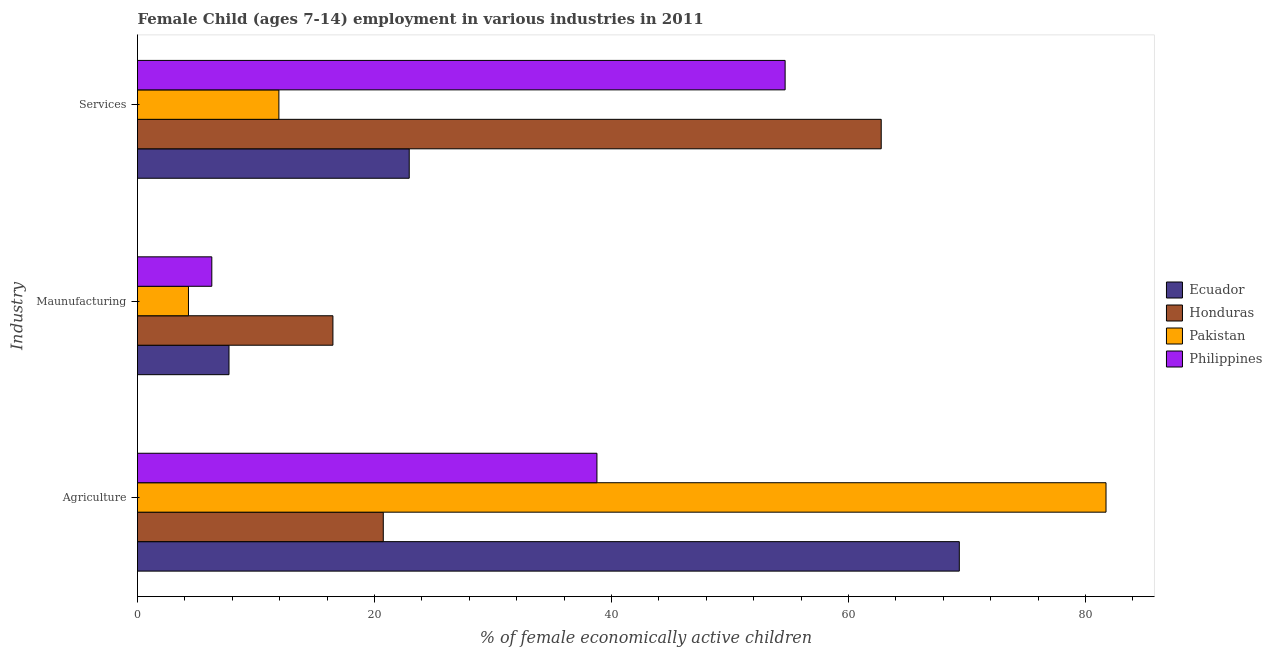How many different coloured bars are there?
Your response must be concise. 4. How many groups of bars are there?
Ensure brevity in your answer.  3. How many bars are there on the 3rd tick from the bottom?
Your answer should be very brief. 4. What is the label of the 3rd group of bars from the top?
Give a very brief answer. Agriculture. What is the percentage of economically active children in services in Pakistan?
Offer a very short reply. 11.93. Across all countries, what is the maximum percentage of economically active children in manufacturing?
Make the answer very short. 16.49. Across all countries, what is the minimum percentage of economically active children in agriculture?
Offer a very short reply. 20.74. What is the total percentage of economically active children in manufacturing in the graph?
Your response must be concise. 34.78. What is the difference between the percentage of economically active children in agriculture in Ecuador and that in Philippines?
Ensure brevity in your answer.  30.58. What is the difference between the percentage of economically active children in services in Pakistan and the percentage of economically active children in manufacturing in Philippines?
Keep it short and to the point. 5.66. What is the average percentage of economically active children in agriculture per country?
Make the answer very short. 52.65. What is the difference between the percentage of economically active children in manufacturing and percentage of economically active children in services in Pakistan?
Provide a short and direct response. -7.63. In how many countries, is the percentage of economically active children in services greater than 64 %?
Your answer should be very brief. 0. What is the ratio of the percentage of economically active children in agriculture in Honduras to that in Ecuador?
Offer a very short reply. 0.3. Is the difference between the percentage of economically active children in services in Ecuador and Honduras greater than the difference between the percentage of economically active children in agriculture in Ecuador and Honduras?
Your answer should be compact. No. What is the difference between the highest and the second highest percentage of economically active children in services?
Keep it short and to the point. 8.11. What is the difference between the highest and the lowest percentage of economically active children in services?
Give a very brief answer. 50.83. In how many countries, is the percentage of economically active children in manufacturing greater than the average percentage of economically active children in manufacturing taken over all countries?
Your answer should be very brief. 1. What does the 2nd bar from the top in Services represents?
Provide a succinct answer. Pakistan. What does the 2nd bar from the bottom in Services represents?
Make the answer very short. Honduras. Is it the case that in every country, the sum of the percentage of economically active children in agriculture and percentage of economically active children in manufacturing is greater than the percentage of economically active children in services?
Give a very brief answer. No. What is the difference between two consecutive major ticks on the X-axis?
Offer a very short reply. 20. How many legend labels are there?
Your response must be concise. 4. What is the title of the graph?
Ensure brevity in your answer.  Female Child (ages 7-14) employment in various industries in 2011. What is the label or title of the X-axis?
Offer a very short reply. % of female economically active children. What is the label or title of the Y-axis?
Your answer should be very brief. Industry. What is the % of female economically active children in Ecuador in Agriculture?
Give a very brief answer. 69.35. What is the % of female economically active children of Honduras in Agriculture?
Your response must be concise. 20.74. What is the % of female economically active children of Pakistan in Agriculture?
Your response must be concise. 81.73. What is the % of female economically active children in Philippines in Agriculture?
Keep it short and to the point. 38.77. What is the % of female economically active children in Ecuador in Maunufacturing?
Keep it short and to the point. 7.72. What is the % of female economically active children in Honduras in Maunufacturing?
Give a very brief answer. 16.49. What is the % of female economically active children of Philippines in Maunufacturing?
Your answer should be compact. 6.27. What is the % of female economically active children in Ecuador in Services?
Ensure brevity in your answer.  22.93. What is the % of female economically active children in Honduras in Services?
Make the answer very short. 62.76. What is the % of female economically active children in Pakistan in Services?
Offer a terse response. 11.93. What is the % of female economically active children in Philippines in Services?
Offer a terse response. 54.65. Across all Industry, what is the maximum % of female economically active children of Ecuador?
Provide a succinct answer. 69.35. Across all Industry, what is the maximum % of female economically active children in Honduras?
Provide a succinct answer. 62.76. Across all Industry, what is the maximum % of female economically active children in Pakistan?
Ensure brevity in your answer.  81.73. Across all Industry, what is the maximum % of female economically active children in Philippines?
Ensure brevity in your answer.  54.65. Across all Industry, what is the minimum % of female economically active children of Ecuador?
Provide a short and direct response. 7.72. Across all Industry, what is the minimum % of female economically active children of Honduras?
Your answer should be compact. 16.49. Across all Industry, what is the minimum % of female economically active children of Philippines?
Make the answer very short. 6.27. What is the total % of female economically active children in Honduras in the graph?
Your response must be concise. 99.99. What is the total % of female economically active children of Pakistan in the graph?
Make the answer very short. 97.96. What is the total % of female economically active children in Philippines in the graph?
Provide a succinct answer. 99.69. What is the difference between the % of female economically active children of Ecuador in Agriculture and that in Maunufacturing?
Ensure brevity in your answer.  61.63. What is the difference between the % of female economically active children of Honduras in Agriculture and that in Maunufacturing?
Keep it short and to the point. 4.25. What is the difference between the % of female economically active children in Pakistan in Agriculture and that in Maunufacturing?
Your response must be concise. 77.43. What is the difference between the % of female economically active children in Philippines in Agriculture and that in Maunufacturing?
Offer a very short reply. 32.5. What is the difference between the % of female economically active children in Ecuador in Agriculture and that in Services?
Make the answer very short. 46.42. What is the difference between the % of female economically active children of Honduras in Agriculture and that in Services?
Provide a succinct answer. -42.02. What is the difference between the % of female economically active children of Pakistan in Agriculture and that in Services?
Offer a very short reply. 69.8. What is the difference between the % of female economically active children of Philippines in Agriculture and that in Services?
Give a very brief answer. -15.88. What is the difference between the % of female economically active children of Ecuador in Maunufacturing and that in Services?
Offer a terse response. -15.21. What is the difference between the % of female economically active children in Honduras in Maunufacturing and that in Services?
Keep it short and to the point. -46.27. What is the difference between the % of female economically active children of Pakistan in Maunufacturing and that in Services?
Offer a very short reply. -7.63. What is the difference between the % of female economically active children in Philippines in Maunufacturing and that in Services?
Provide a short and direct response. -48.38. What is the difference between the % of female economically active children of Ecuador in Agriculture and the % of female economically active children of Honduras in Maunufacturing?
Your response must be concise. 52.86. What is the difference between the % of female economically active children of Ecuador in Agriculture and the % of female economically active children of Pakistan in Maunufacturing?
Offer a very short reply. 65.05. What is the difference between the % of female economically active children of Ecuador in Agriculture and the % of female economically active children of Philippines in Maunufacturing?
Your answer should be very brief. 63.08. What is the difference between the % of female economically active children in Honduras in Agriculture and the % of female economically active children in Pakistan in Maunufacturing?
Provide a succinct answer. 16.44. What is the difference between the % of female economically active children of Honduras in Agriculture and the % of female economically active children of Philippines in Maunufacturing?
Ensure brevity in your answer.  14.47. What is the difference between the % of female economically active children of Pakistan in Agriculture and the % of female economically active children of Philippines in Maunufacturing?
Ensure brevity in your answer.  75.46. What is the difference between the % of female economically active children in Ecuador in Agriculture and the % of female economically active children in Honduras in Services?
Your response must be concise. 6.59. What is the difference between the % of female economically active children in Ecuador in Agriculture and the % of female economically active children in Pakistan in Services?
Offer a very short reply. 57.42. What is the difference between the % of female economically active children in Honduras in Agriculture and the % of female economically active children in Pakistan in Services?
Offer a very short reply. 8.81. What is the difference between the % of female economically active children in Honduras in Agriculture and the % of female economically active children in Philippines in Services?
Your response must be concise. -33.91. What is the difference between the % of female economically active children of Pakistan in Agriculture and the % of female economically active children of Philippines in Services?
Offer a very short reply. 27.08. What is the difference between the % of female economically active children in Ecuador in Maunufacturing and the % of female economically active children in Honduras in Services?
Provide a succinct answer. -55.04. What is the difference between the % of female economically active children in Ecuador in Maunufacturing and the % of female economically active children in Pakistan in Services?
Your answer should be compact. -4.21. What is the difference between the % of female economically active children in Ecuador in Maunufacturing and the % of female economically active children in Philippines in Services?
Keep it short and to the point. -46.93. What is the difference between the % of female economically active children of Honduras in Maunufacturing and the % of female economically active children of Pakistan in Services?
Provide a succinct answer. 4.56. What is the difference between the % of female economically active children in Honduras in Maunufacturing and the % of female economically active children in Philippines in Services?
Your response must be concise. -38.16. What is the difference between the % of female economically active children of Pakistan in Maunufacturing and the % of female economically active children of Philippines in Services?
Provide a short and direct response. -50.35. What is the average % of female economically active children of Ecuador per Industry?
Make the answer very short. 33.33. What is the average % of female economically active children in Honduras per Industry?
Provide a short and direct response. 33.33. What is the average % of female economically active children in Pakistan per Industry?
Make the answer very short. 32.65. What is the average % of female economically active children of Philippines per Industry?
Your answer should be very brief. 33.23. What is the difference between the % of female economically active children in Ecuador and % of female economically active children in Honduras in Agriculture?
Keep it short and to the point. 48.61. What is the difference between the % of female economically active children of Ecuador and % of female economically active children of Pakistan in Agriculture?
Offer a very short reply. -12.38. What is the difference between the % of female economically active children of Ecuador and % of female economically active children of Philippines in Agriculture?
Offer a terse response. 30.58. What is the difference between the % of female economically active children in Honduras and % of female economically active children in Pakistan in Agriculture?
Your response must be concise. -60.99. What is the difference between the % of female economically active children in Honduras and % of female economically active children in Philippines in Agriculture?
Your response must be concise. -18.03. What is the difference between the % of female economically active children in Pakistan and % of female economically active children in Philippines in Agriculture?
Your response must be concise. 42.96. What is the difference between the % of female economically active children of Ecuador and % of female economically active children of Honduras in Maunufacturing?
Your answer should be very brief. -8.77. What is the difference between the % of female economically active children in Ecuador and % of female economically active children in Pakistan in Maunufacturing?
Give a very brief answer. 3.42. What is the difference between the % of female economically active children in Ecuador and % of female economically active children in Philippines in Maunufacturing?
Your response must be concise. 1.45. What is the difference between the % of female economically active children in Honduras and % of female economically active children in Pakistan in Maunufacturing?
Give a very brief answer. 12.19. What is the difference between the % of female economically active children in Honduras and % of female economically active children in Philippines in Maunufacturing?
Your response must be concise. 10.22. What is the difference between the % of female economically active children of Pakistan and % of female economically active children of Philippines in Maunufacturing?
Keep it short and to the point. -1.97. What is the difference between the % of female economically active children of Ecuador and % of female economically active children of Honduras in Services?
Your answer should be very brief. -39.83. What is the difference between the % of female economically active children in Ecuador and % of female economically active children in Philippines in Services?
Your response must be concise. -31.72. What is the difference between the % of female economically active children of Honduras and % of female economically active children of Pakistan in Services?
Make the answer very short. 50.83. What is the difference between the % of female economically active children in Honduras and % of female economically active children in Philippines in Services?
Offer a very short reply. 8.11. What is the difference between the % of female economically active children of Pakistan and % of female economically active children of Philippines in Services?
Offer a very short reply. -42.72. What is the ratio of the % of female economically active children in Ecuador in Agriculture to that in Maunufacturing?
Keep it short and to the point. 8.98. What is the ratio of the % of female economically active children in Honduras in Agriculture to that in Maunufacturing?
Give a very brief answer. 1.26. What is the ratio of the % of female economically active children of Pakistan in Agriculture to that in Maunufacturing?
Provide a succinct answer. 19.01. What is the ratio of the % of female economically active children of Philippines in Agriculture to that in Maunufacturing?
Keep it short and to the point. 6.18. What is the ratio of the % of female economically active children of Ecuador in Agriculture to that in Services?
Keep it short and to the point. 3.02. What is the ratio of the % of female economically active children of Honduras in Agriculture to that in Services?
Your answer should be very brief. 0.33. What is the ratio of the % of female economically active children in Pakistan in Agriculture to that in Services?
Your response must be concise. 6.85. What is the ratio of the % of female economically active children in Philippines in Agriculture to that in Services?
Make the answer very short. 0.71. What is the ratio of the % of female economically active children of Ecuador in Maunufacturing to that in Services?
Make the answer very short. 0.34. What is the ratio of the % of female economically active children of Honduras in Maunufacturing to that in Services?
Your answer should be very brief. 0.26. What is the ratio of the % of female economically active children in Pakistan in Maunufacturing to that in Services?
Offer a terse response. 0.36. What is the ratio of the % of female economically active children in Philippines in Maunufacturing to that in Services?
Give a very brief answer. 0.11. What is the difference between the highest and the second highest % of female economically active children of Ecuador?
Your answer should be compact. 46.42. What is the difference between the highest and the second highest % of female economically active children in Honduras?
Your answer should be compact. 42.02. What is the difference between the highest and the second highest % of female economically active children of Pakistan?
Your answer should be very brief. 69.8. What is the difference between the highest and the second highest % of female economically active children in Philippines?
Provide a succinct answer. 15.88. What is the difference between the highest and the lowest % of female economically active children in Ecuador?
Provide a succinct answer. 61.63. What is the difference between the highest and the lowest % of female economically active children of Honduras?
Your response must be concise. 46.27. What is the difference between the highest and the lowest % of female economically active children of Pakistan?
Make the answer very short. 77.43. What is the difference between the highest and the lowest % of female economically active children in Philippines?
Ensure brevity in your answer.  48.38. 